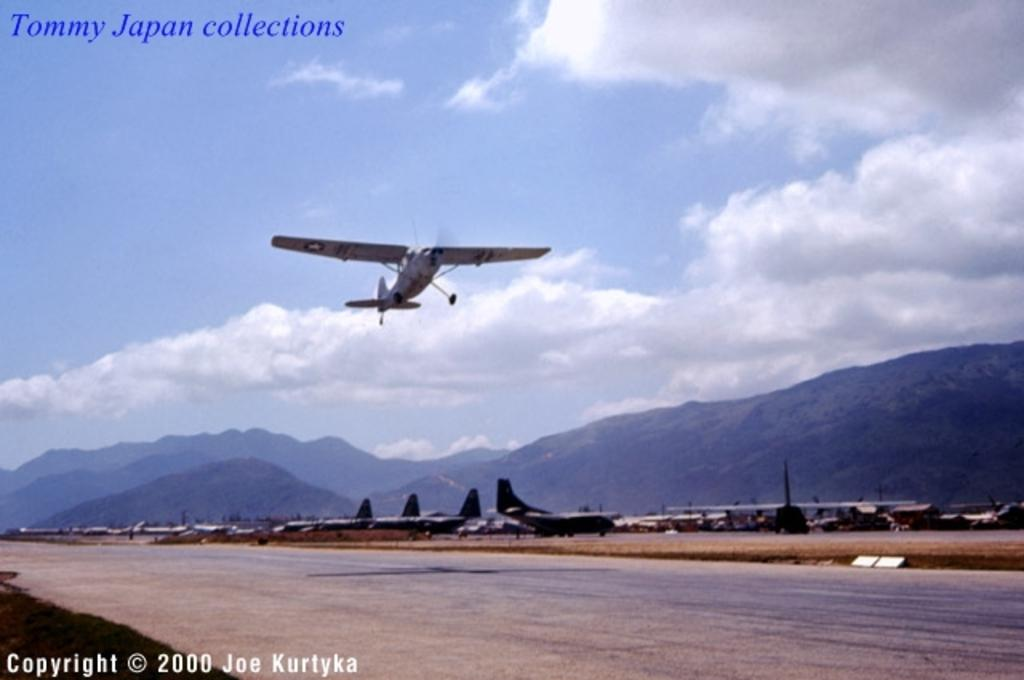What is the main subject of the picture? The main subject of the picture is airplanes. Can you describe the position of one of the airplanes? One airplane is flying in the air. What can be seen in the background of the picture? There is sky and mountains visible in the background of the picture. Are there any visible marks on the image? Yes, watermarks are present on the image. What type of calculator can be seen on the wing of the airplane in the image? There is no calculator visible on the wing of the airplane in the image. What system is being used to control the airplane in the image? The image does not provide information about the control system of the airplane. 